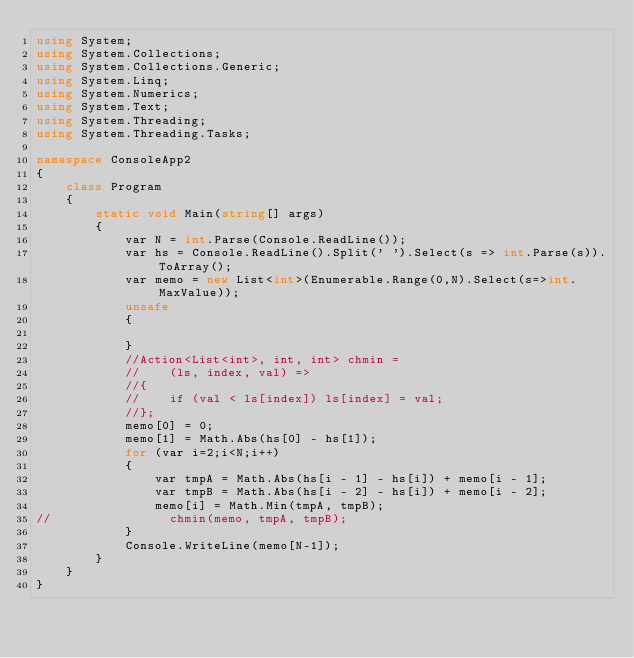<code> <loc_0><loc_0><loc_500><loc_500><_C#_>using System;
using System.Collections;
using System.Collections.Generic;
using System.Linq;
using System.Numerics;
using System.Text;
using System.Threading;
using System.Threading.Tasks;

namespace ConsoleApp2
{
    class Program
    {
        static void Main(string[] args)
        {
            var N = int.Parse(Console.ReadLine());
            var hs = Console.ReadLine().Split(' ').Select(s => int.Parse(s)).ToArray();
            var memo = new List<int>(Enumerable.Range(0,N).Select(s=>int.MaxValue));
            unsafe
            {

            }
            //Action<List<int>, int, int> chmin = 
            //    (ls, index, val) => 
            //{
            //    if (val < ls[index]) ls[index] = val;
            //};
            memo[0] = 0;
            memo[1] = Math.Abs(hs[0] - hs[1]);
            for (var i=2;i<N;i++)
            {
                var tmpA = Math.Abs(hs[i - 1] - hs[i]) + memo[i - 1];
                var tmpB = Math.Abs(hs[i - 2] - hs[i]) + memo[i - 2];
                memo[i] = Math.Min(tmpA, tmpB);
//                chmin(memo, tmpA, tmpB);
            }
            Console.WriteLine(memo[N-1]);
        }
    }
}
</code> 